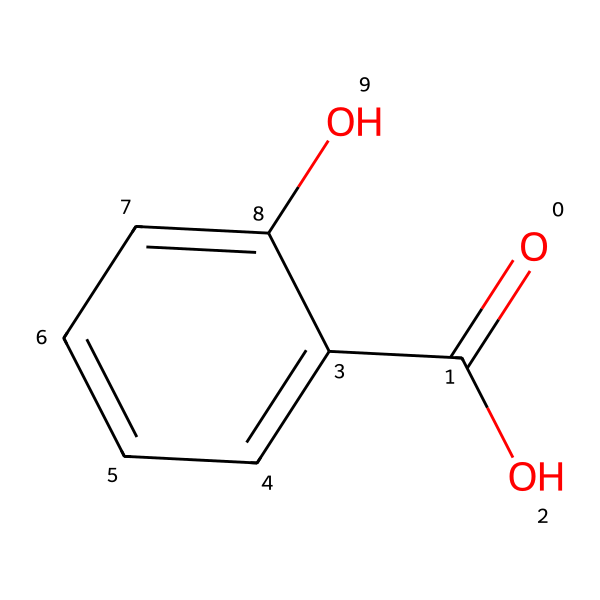What is the molecular formula of salicylic acid? To determine the molecular formula, count the number of each type of atom in the SMILES representation. The structure contains 7 carbon atoms (C), 6 hydrogen atoms (H), and 3 oxygen atoms (O), giving a total formula of C7H6O3.
Answer: C7H6O3 How many hydroxyl groups are present in salicylic acid? The presence of the hydroxyl functional group (-OH) can be identified in the chemical structure. In the SMILES, there is one -OH group attached to the aromatic ring and one carboxylic acid (-COOH) group that contains a hydroxyl. Thus, there are 2 hydroxyl groups in total.
Answer: 2 What type of functional groups are featured in salicylic acid? The functional groups in the SMILES representation are carboxylic acid (-COOH) and hydroxyl (-OH). The carboxylic acid is indicated by the -C(=O)O, and the two -OH groups from the aromatic ring and the carboxyl group reveal the presence of hydroxyl groups.
Answer: carboxylic acid and hydroxyl Which aromatic compound is closely related to salicylic acid? The structure of salicylic acid includes a phenolic ring — the base structure for many aromatic compounds. This specific structure makes it closely related to phenol, which is also a simple aromatic compound with a hydroxyl group attached to a benzene ring.
Answer: phenol What is the significance of the carboxylic acid group in salicylic acid? The carboxylic acid group (-COOH) contributes to the acidity properties of salicylic acid. Its presence in the structure affects the solubility and reactivity in cosmetic applications, allowing it to exfoliate and penetrate the skin more effectively.
Answer: acidity properties How does the presence of the hydroxyl group influence salicylic acid's function in cosmetics? Hydroxyl substituents enhance the solubility of salicylic acid in water, which is essential for its function as a skin exfoliant. The hydroxyl group's polarity helps it interact with skin cells, allowing it to effectively remove dead skin and unclog pores.
Answer: enhances solubility 